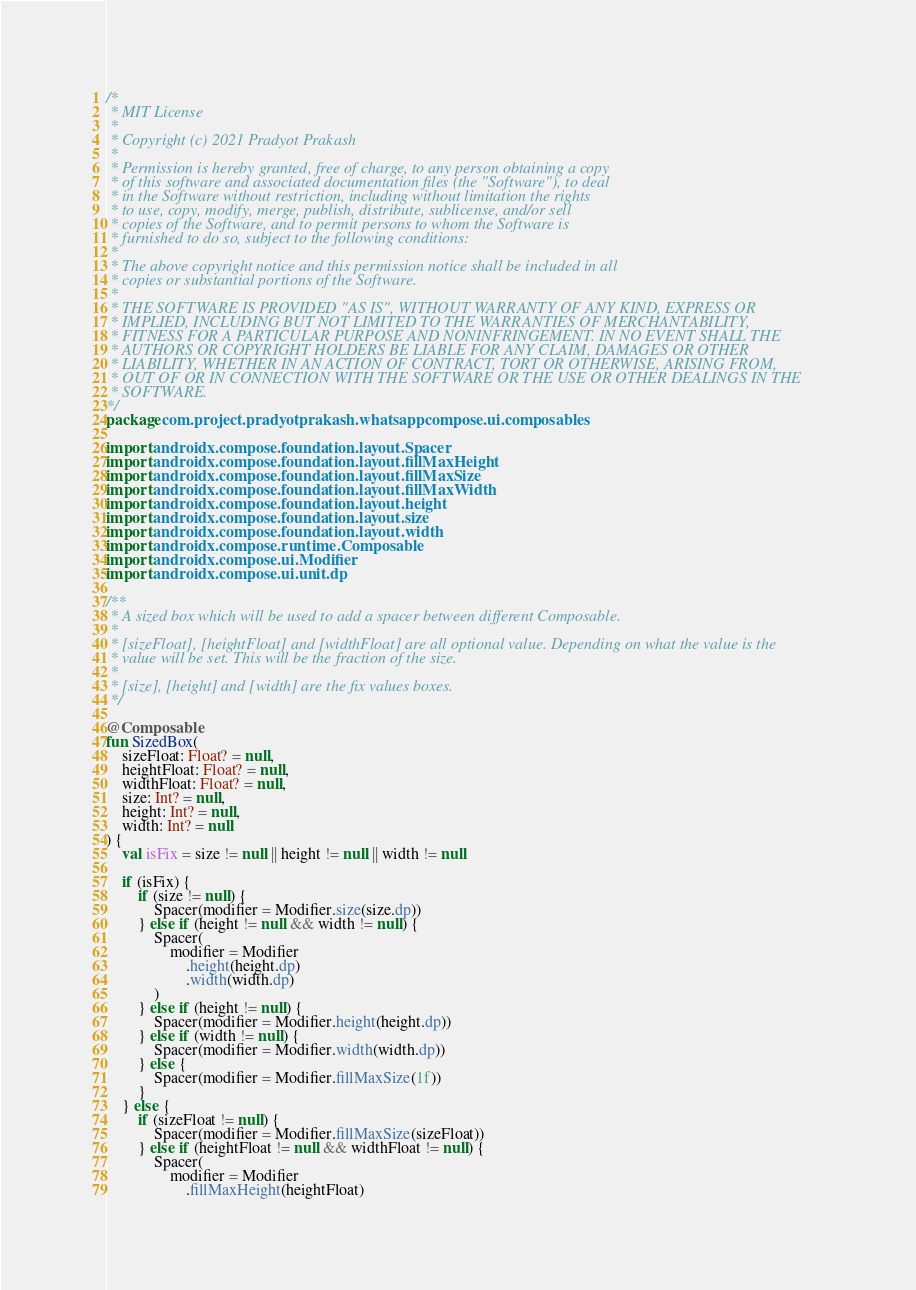<code> <loc_0><loc_0><loc_500><loc_500><_Kotlin_>/*
 * MIT License
 *
 * Copyright (c) 2021 Pradyot Prakash
 *
 * Permission is hereby granted, free of charge, to any person obtaining a copy
 * of this software and associated documentation files (the "Software"), to deal
 * in the Software without restriction, including without limitation the rights
 * to use, copy, modify, merge, publish, distribute, sublicense, and/or sell
 * copies of the Software, and to permit persons to whom the Software is
 * furnished to do so, subject to the following conditions:
 *
 * The above copyright notice and this permission notice shall be included in all
 * copies or substantial portions of the Software.
 *
 * THE SOFTWARE IS PROVIDED "AS IS", WITHOUT WARRANTY OF ANY KIND, EXPRESS OR
 * IMPLIED, INCLUDING BUT NOT LIMITED TO THE WARRANTIES OF MERCHANTABILITY,
 * FITNESS FOR A PARTICULAR PURPOSE AND NONINFRINGEMENT. IN NO EVENT SHALL THE
 * AUTHORS OR COPYRIGHT HOLDERS BE LIABLE FOR ANY CLAIM, DAMAGES OR OTHER
 * LIABILITY, WHETHER IN AN ACTION OF CONTRACT, TORT OR OTHERWISE, ARISING FROM,
 * OUT OF OR IN CONNECTION WITH THE SOFTWARE OR THE USE OR OTHER DEALINGS IN THE
 * SOFTWARE.
*/
package com.project.pradyotprakash.whatsappcompose.ui.composables

import androidx.compose.foundation.layout.Spacer
import androidx.compose.foundation.layout.fillMaxHeight
import androidx.compose.foundation.layout.fillMaxSize
import androidx.compose.foundation.layout.fillMaxWidth
import androidx.compose.foundation.layout.height
import androidx.compose.foundation.layout.size
import androidx.compose.foundation.layout.width
import androidx.compose.runtime.Composable
import androidx.compose.ui.Modifier
import androidx.compose.ui.unit.dp

/**
 * A sized box which will be used to add a spacer between different Composable.
 *
 * [sizeFloat], [heightFloat] and [widthFloat] are all optional value. Depending on what the value is the
 * value will be set. This will be the fraction of the size.
 *
 * [size], [height] and [width] are the fix values boxes.
 */

@Composable
fun SizedBox(
    sizeFloat: Float? = null,
    heightFloat: Float? = null,
    widthFloat: Float? = null,
    size: Int? = null,
    height: Int? = null,
    width: Int? = null
) {
    val isFix = size != null || height != null || width != null

    if (isFix) {
        if (size != null) {
            Spacer(modifier = Modifier.size(size.dp))
        } else if (height != null && width != null) {
            Spacer(
                modifier = Modifier
                    .height(height.dp)
                    .width(width.dp)
            )
        } else if (height != null) {
            Spacer(modifier = Modifier.height(height.dp))
        } else if (width != null) {
            Spacer(modifier = Modifier.width(width.dp))
        } else {
            Spacer(modifier = Modifier.fillMaxSize(1f))
        }
    } else {
        if (sizeFloat != null) {
            Spacer(modifier = Modifier.fillMaxSize(sizeFloat))
        } else if (heightFloat != null && widthFloat != null) {
            Spacer(
                modifier = Modifier
                    .fillMaxHeight(heightFloat)</code> 